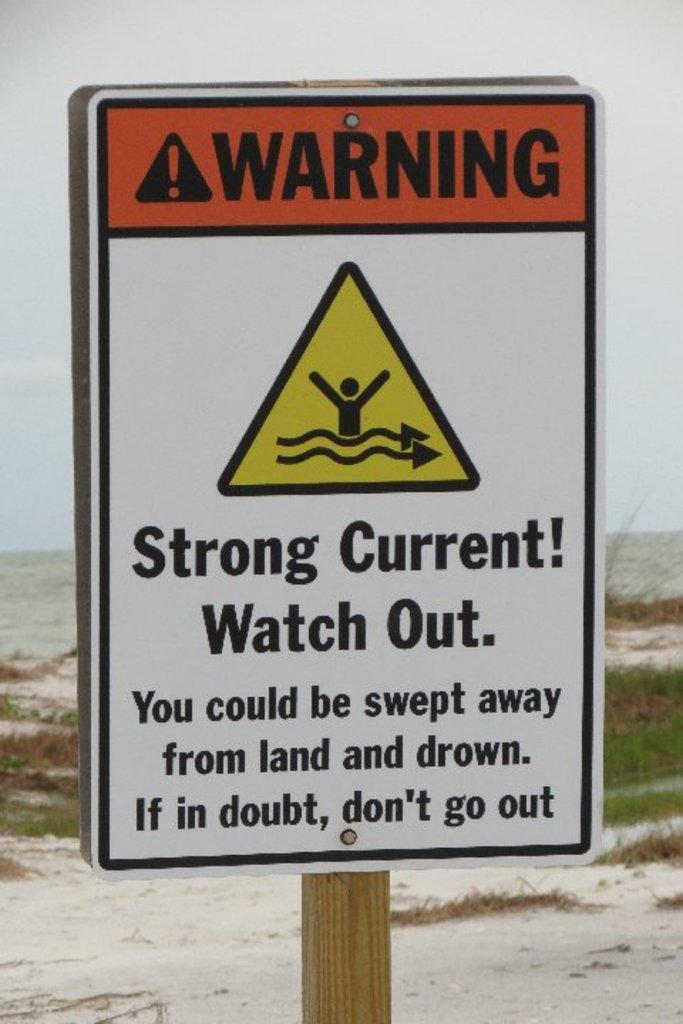What is the main object in the image? There is a name board in the image. How is the name board supported? The name board is supported by a wooden pole. What can be seen in the background of the image? There is grass, the ground, and the sky visible in the background of the image. What hobbies are the people in the image engaged in? There are no people present in the image, so their hobbies cannot be determined. Is there a drain visible in the image? There is no drain present in the image. 